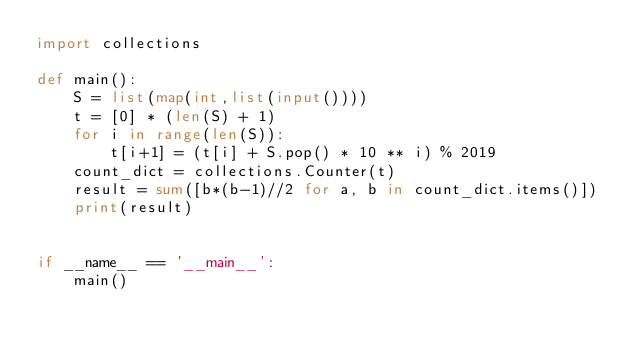<code> <loc_0><loc_0><loc_500><loc_500><_Python_>import collections

def main():
    S = list(map(int,list(input())))
    t = [0] * (len(S) + 1)
    for i in range(len(S)):
        t[i+1] = (t[i] + S.pop() * 10 ** i) % 2019
    count_dict = collections.Counter(t)
    result = sum([b*(b-1)//2 for a, b in count_dict.items()])
    print(result)


if __name__ == '__main__':
    main()
</code> 